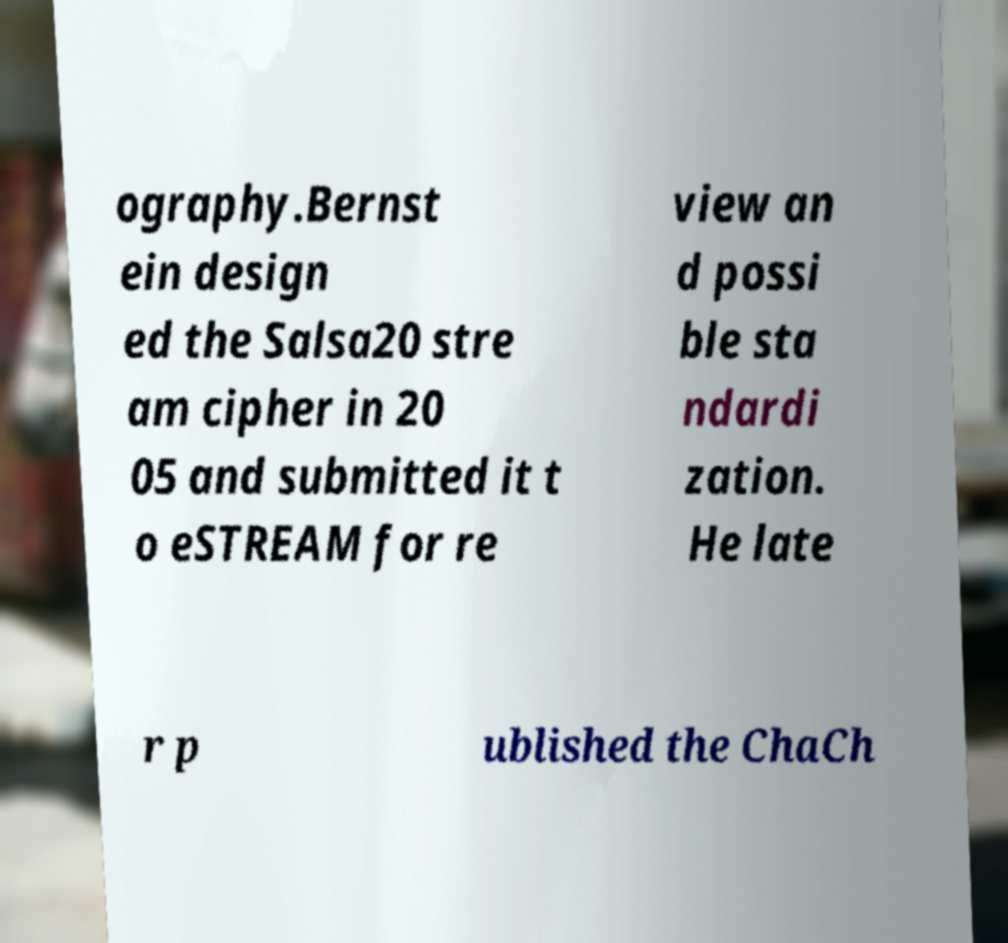What messages or text are displayed in this image? I need them in a readable, typed format. ography.Bernst ein design ed the Salsa20 stre am cipher in 20 05 and submitted it t o eSTREAM for re view an d possi ble sta ndardi zation. He late r p ublished the ChaCh 